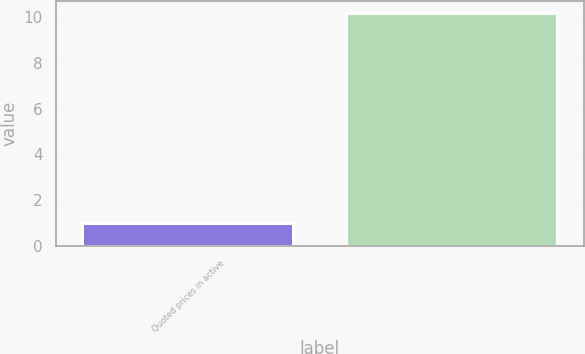Convert chart. <chart><loc_0><loc_0><loc_500><loc_500><bar_chart><fcel>Quoted prices in active<fcel>Unnamed: 1<nl><fcel>1<fcel>10.2<nl></chart> 